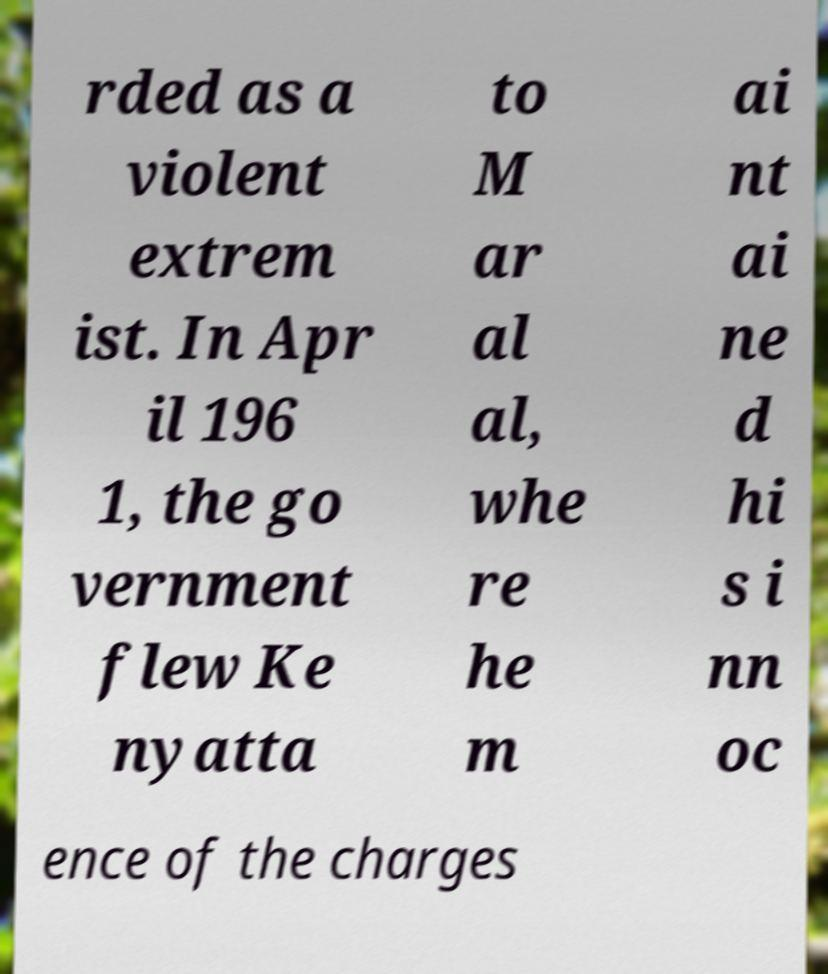Can you read and provide the text displayed in the image?This photo seems to have some interesting text. Can you extract and type it out for me? rded as a violent extrem ist. In Apr il 196 1, the go vernment flew Ke nyatta to M ar al al, whe re he m ai nt ai ne d hi s i nn oc ence of the charges 